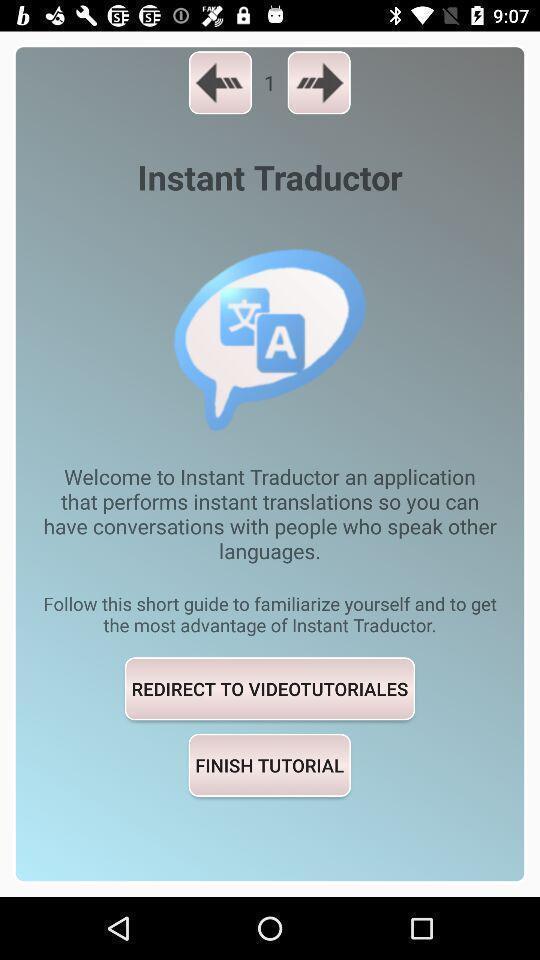Provide a description of this screenshot. Welcome page of social app. 